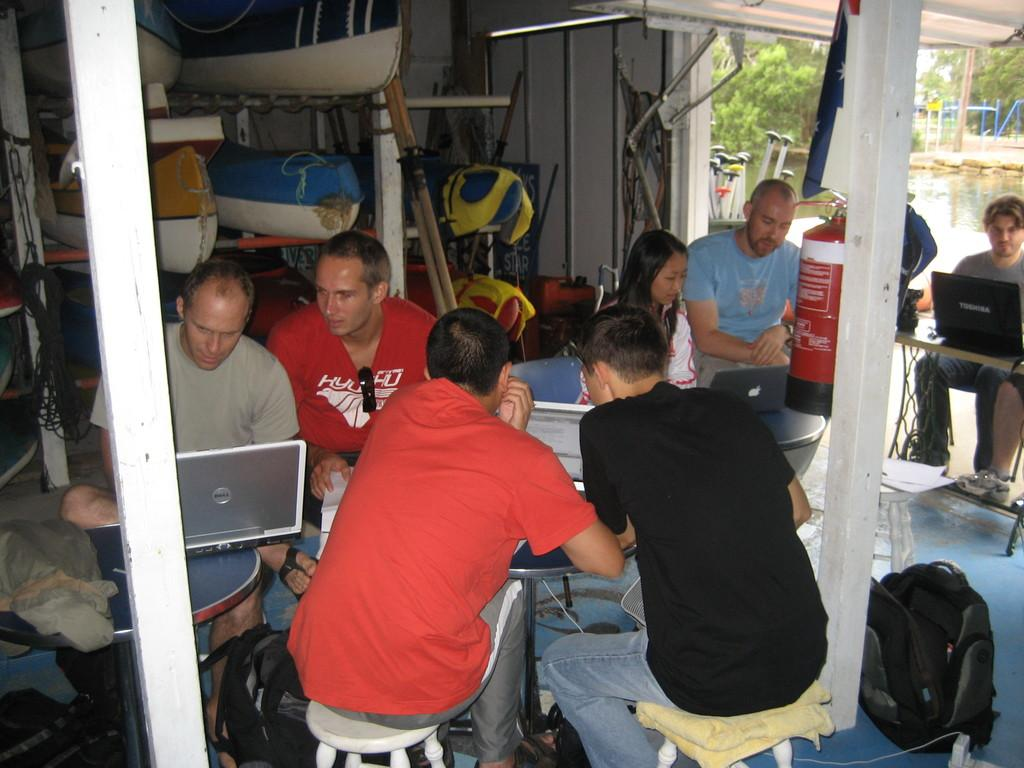What are the people near the tables doing in the image? The people are sitting on chairs near tables and holding laptops. What safety device can be seen in the image? There is a fire extinguisher in the image. What can be seen in the background of the image? Boats, water, and trees are visible in the background. What type of paste is being used by the people in the image? There is no paste visible or mentioned in the image; the people are holding laptops. How many marks can be seen on the boats in the background? There are no marks visible on the boats in the background; only the boats themselves and the water are mentioned. 